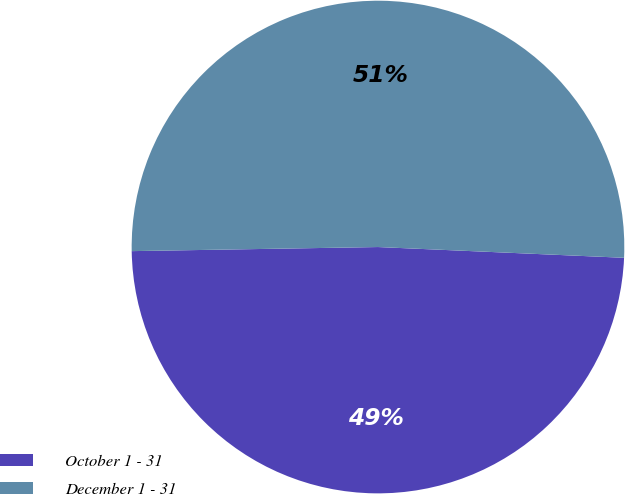<chart> <loc_0><loc_0><loc_500><loc_500><pie_chart><fcel>October 1 - 31<fcel>December 1 - 31<nl><fcel>49.04%<fcel>50.96%<nl></chart> 